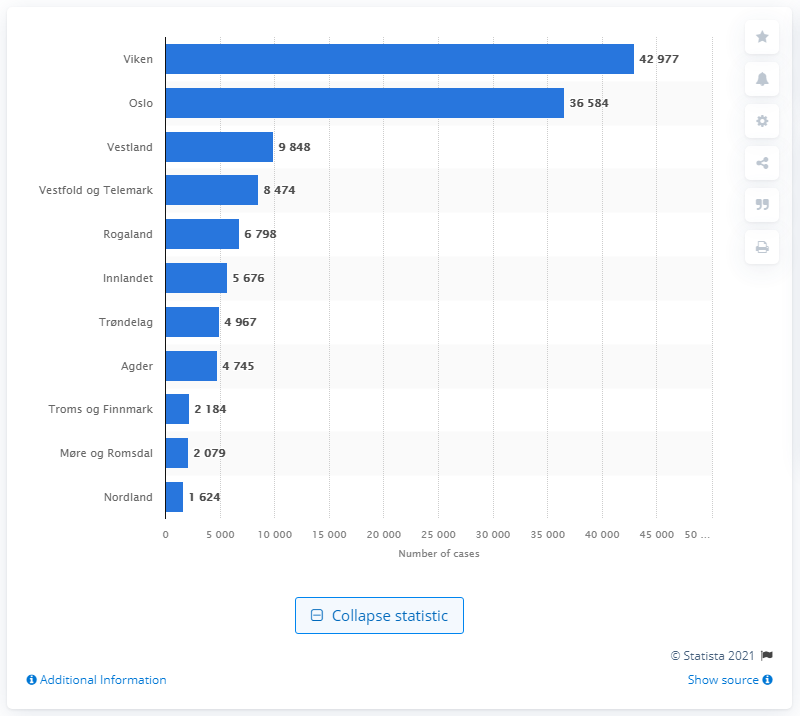Mention a couple of crucial points in this snapshot. Oslo is the capital of Norway. On June 15, 2021, the highest number of confirmed coronavirus cases in Norway was in Viken. 